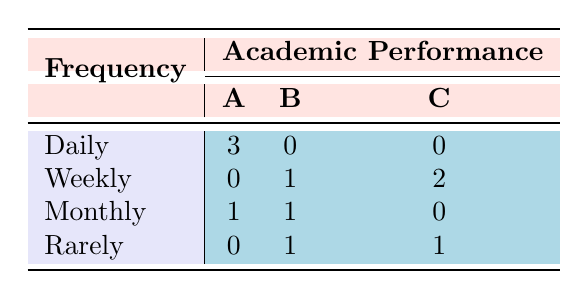What percentage of students read Shakespeare's sonnets daily? There are 10 students in total, and 3 of them read sonnets daily. To find the percentage, divide the number of daily readers by the total number of students: (3/10) * 100 = 30%.
Answer: 30% How many students perform at level C while reading Shakespeare's sonnets weekly? Looking at the table, there are 2 students who read weekly and perform at level C.
Answer: 2 Is there any student who reads Shakespeare's sonnets rarely and has an academic performance of A? By examining the table, there are 0 students listed under the category of "Rarely" who have an academic performance of A.
Answer: No What is the total number of students who read Shakespeare's sonnets monthly? The table indicates that there is a total of 2 students who read sonnets monthly (1 with performance A and 1 with performance B).
Answer: 2 Which frequency of reading has the highest academic performance based on the data? Daily reading has the highest academic performance with 3 students achieving an A, while other frequencies have lower performances.
Answer: Daily Are there more students who read Shakespeare's sonnets weekly or monthly? From the table, 3 students (1 B and 2 C) read weekly, whereas 2 students (1 A and 1 B) read monthly. Thus, there are more weekly readers.
Answer: Weekly What is the total number of students with an academic performance of B? From the table, there are 3 students who have a performance of B (1 from monthly, 1 from rarely, and 1 from weekly).
Answer: 3 If a student reads Shakespeare's sonnets daily, what is the likelihood they will have an academic performance of A compared to the total number of daily readers? Out of 3 daily readers, all 3 have an academic performance of A. Therefore, the likelihood is 100%.
Answer: 100% What is the difference in the number of students reading daily and those reading rarely? There are 3 students who read daily and 2 students who read rarely. The difference is 3 - 2 = 1.
Answer: 1 